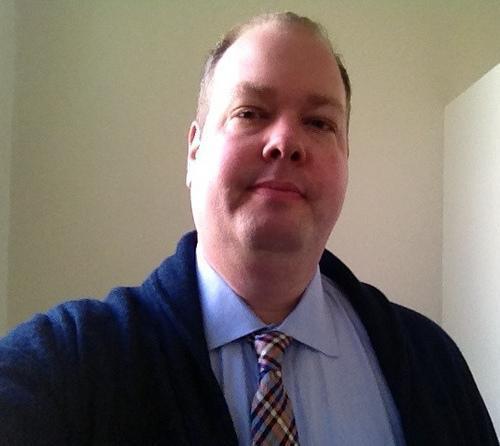How many men in the room?
Give a very brief answer. 1. 